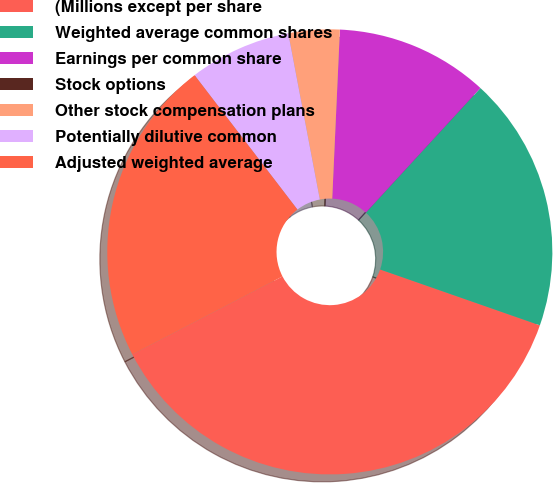<chart> <loc_0><loc_0><loc_500><loc_500><pie_chart><fcel>(Millions except per share<fcel>Weighted average common shares<fcel>Earnings per common share<fcel>Stock options<fcel>Other stock compensation plans<fcel>Potentially dilutive common<fcel>Adjusted weighted average<nl><fcel>37.03%<fcel>18.52%<fcel>11.11%<fcel>0.0%<fcel>3.71%<fcel>7.41%<fcel>22.22%<nl></chart> 